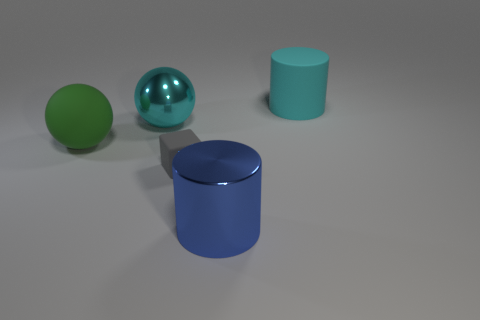How many things are yellow spheres or big things to the right of the big metal cylinder?
Ensure brevity in your answer.  1. What is the size of the cyan thing left of the matte object to the right of the block?
Offer a terse response. Large. Are there an equal number of metallic cylinders that are behind the large blue thing and big cyan metal things that are behind the cube?
Provide a short and direct response. No. There is a big cyan object that is left of the cyan rubber object; are there any cyan metallic spheres in front of it?
Make the answer very short. No. There is a big green object that is made of the same material as the gray object; what shape is it?
Your answer should be compact. Sphere. Is there any other thing that has the same color as the metal ball?
Offer a terse response. Yes. What material is the cyan thing behind the shiny thing that is behind the blue shiny thing?
Provide a short and direct response. Rubber. Is there another small thing that has the same shape as the blue metal thing?
Provide a short and direct response. No. What number of other things are the same shape as the big green object?
Provide a succinct answer. 1. The big object that is in front of the big cyan shiny ball and right of the small object has what shape?
Provide a succinct answer. Cylinder. 